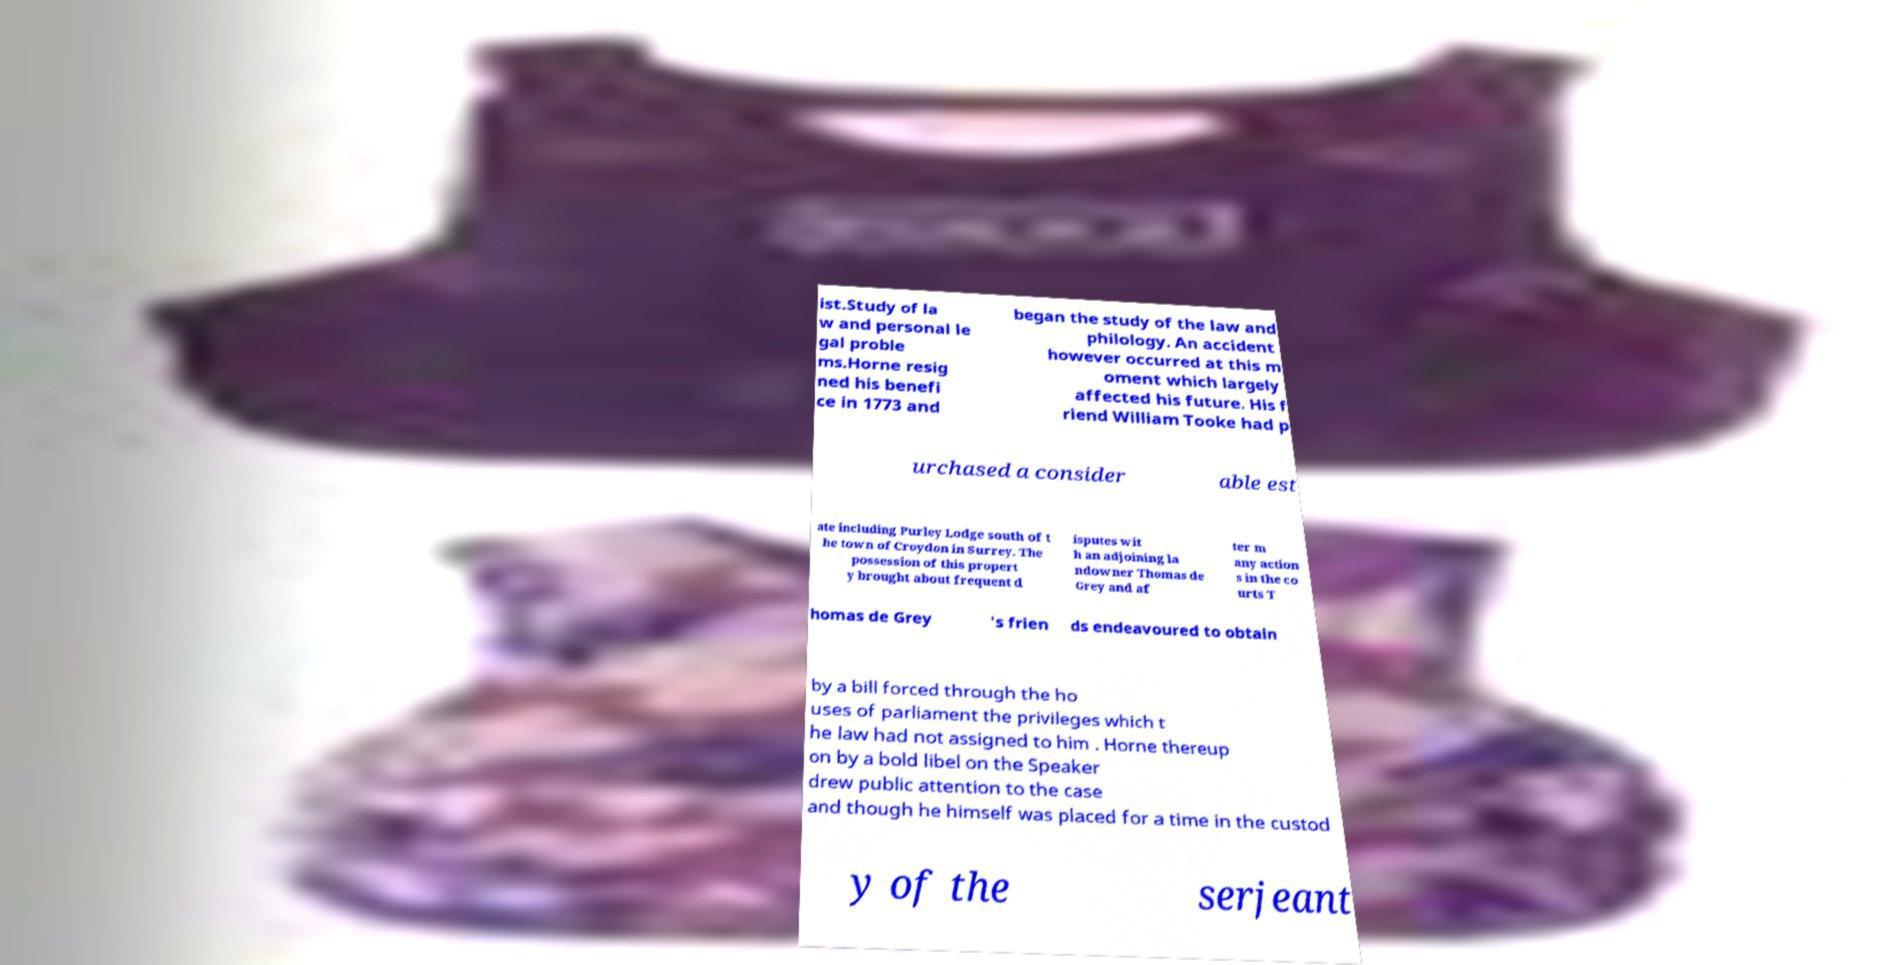Can you read and provide the text displayed in the image?This photo seems to have some interesting text. Can you extract and type it out for me? ist.Study of la w and personal le gal proble ms.Horne resig ned his benefi ce in 1773 and began the study of the law and philology. An accident however occurred at this m oment which largely affected his future. His f riend William Tooke had p urchased a consider able est ate including Purley Lodge south of t he town of Croydon in Surrey. The possession of this propert y brought about frequent d isputes wit h an adjoining la ndowner Thomas de Grey and af ter m any action s in the co urts T homas de Grey 's frien ds endeavoured to obtain by a bill forced through the ho uses of parliament the privileges which t he law had not assigned to him . Horne thereup on by a bold libel on the Speaker drew public attention to the case and though he himself was placed for a time in the custod y of the serjeant 